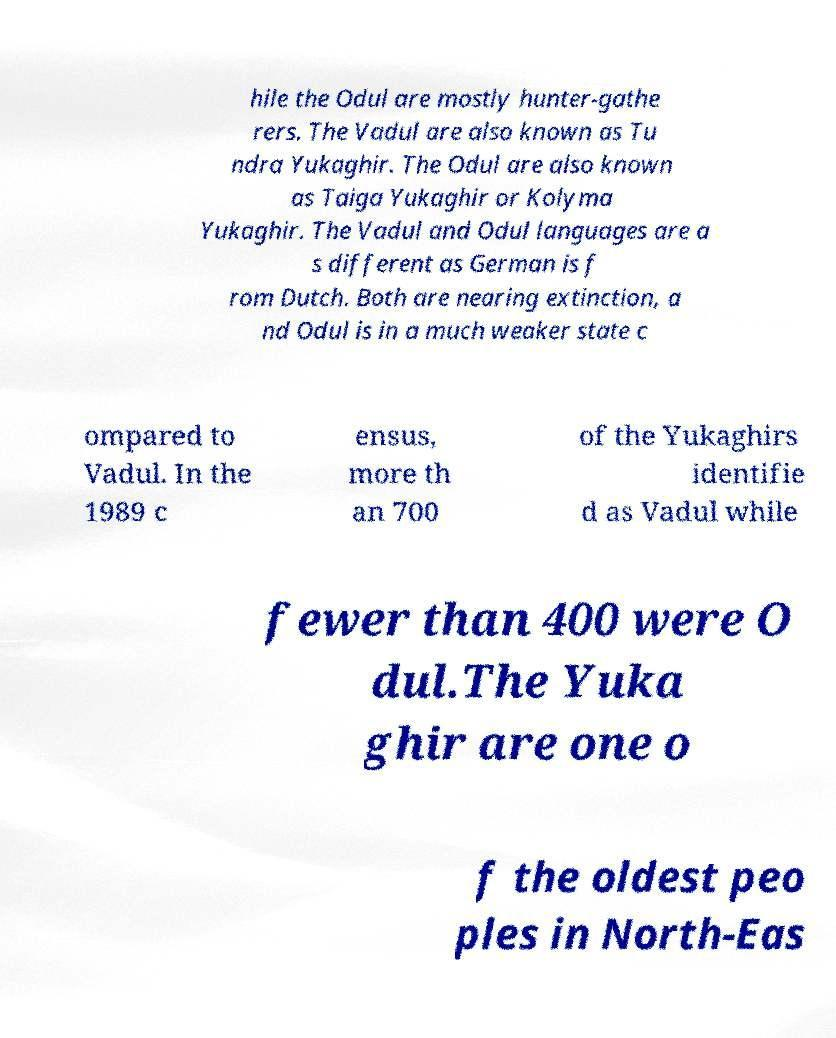What messages or text are displayed in this image? I need them in a readable, typed format. hile the Odul are mostly hunter-gathe rers. The Vadul are also known as Tu ndra Yukaghir. The Odul are also known as Taiga Yukaghir or Kolyma Yukaghir. The Vadul and Odul languages are a s different as German is f rom Dutch. Both are nearing extinction, a nd Odul is in a much weaker state c ompared to Vadul. In the 1989 c ensus, more th an 700 of the Yukaghirs identifie d as Vadul while fewer than 400 were O dul.The Yuka ghir are one o f the oldest peo ples in North-Eas 